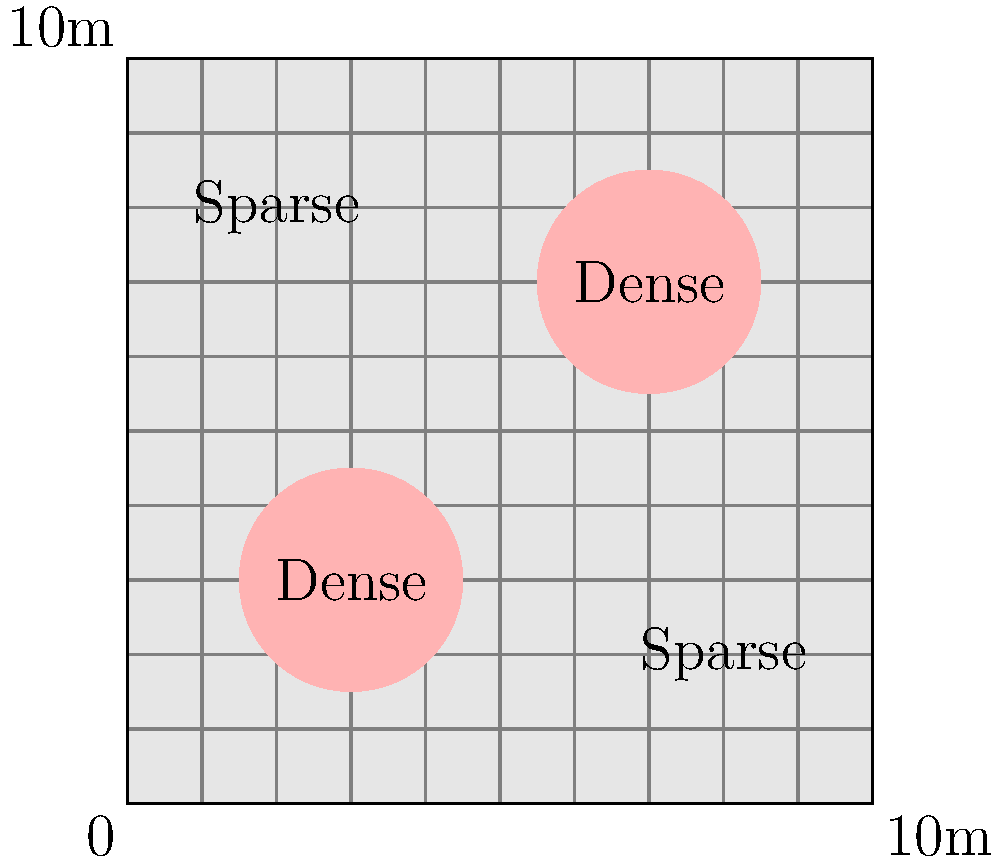As a local musician collaborating with a DJ to showcase Canadian talent, you're performing at an outdoor event. The organizers have provided you with an aerial photograph of the venue, represented by the diagram above. The image shows a 10m x 10m area with two dense crowd regions (shown in pink) and two sparse regions. If the dense areas have approximately 4 people per square meter and the sparse areas have 1 person per square meter, estimate the total crowd size at this event. Let's break this down step-by-step:

1. Calculate the area of dense regions:
   - Each dense region is a circle with a radius of 1.5m
   - Area of one dense region = $\pi r^2 = \pi (1.5)^2 \approx 7.07$ m²
   - Total dense area = $2 \times 7.07 \approx 14.14$ m²

2. Calculate the total event area:
   - Total area = $10\text{m} \times 10\text{m} = 100$ m²

3. Calculate the sparse area:
   - Sparse area = Total area - Dense area
   - Sparse area = $100 - 14.14 = 85.86$ m²

4. Calculate the number of people in dense areas:
   - Density in dense areas = 4 people/m²
   - People in dense areas = $14.14 \text{ m}^2 \times 4 \text{ people/m}^2 \approx 56.56$

5. Calculate the number of people in sparse areas:
   - Density in sparse areas = 1 person/m²
   - People in sparse areas = $85.86 \text{ m}^2 \times 1 \text{ person/m}^2 \approx 85.86$

6. Sum up the total number of people:
   - Total crowd = People in dense areas + People in sparse areas
   - Total crowd = $56.56 + 85.86 \approx 142.42$

7. Round to a reasonable estimate:
   - Crowd size estimate ≈ 140 people
Answer: Approximately 140 people 